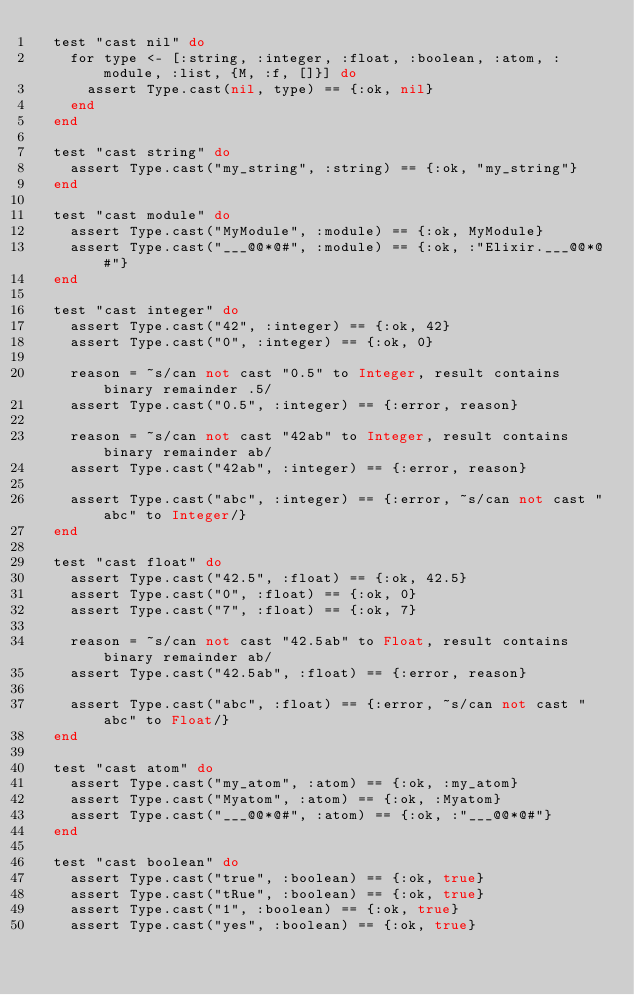Convert code to text. <code><loc_0><loc_0><loc_500><loc_500><_Elixir_>  test "cast nil" do
    for type <- [:string, :integer, :float, :boolean, :atom, :module, :list, {M, :f, []}] do
      assert Type.cast(nil, type) == {:ok, nil}
    end
  end

  test "cast string" do
    assert Type.cast("my_string", :string) == {:ok, "my_string"}
  end

  test "cast module" do
    assert Type.cast("MyModule", :module) == {:ok, MyModule}
    assert Type.cast("___@@*@#", :module) == {:ok, :"Elixir.___@@*@#"}
  end

  test "cast integer" do
    assert Type.cast("42", :integer) == {:ok, 42}
    assert Type.cast("0", :integer) == {:ok, 0}

    reason = ~s/can not cast "0.5" to Integer, result contains binary remainder .5/
    assert Type.cast("0.5", :integer) == {:error, reason}

    reason = ~s/can not cast "42ab" to Integer, result contains binary remainder ab/
    assert Type.cast("42ab", :integer) == {:error, reason}

    assert Type.cast("abc", :integer) == {:error, ~s/can not cast "abc" to Integer/}
  end

  test "cast float" do
    assert Type.cast("42.5", :float) == {:ok, 42.5}
    assert Type.cast("0", :float) == {:ok, 0}
    assert Type.cast("7", :float) == {:ok, 7}

    reason = ~s/can not cast "42.5ab" to Float, result contains binary remainder ab/
    assert Type.cast("42.5ab", :float) == {:error, reason}

    assert Type.cast("abc", :float) == {:error, ~s/can not cast "abc" to Float/}
  end

  test "cast atom" do
    assert Type.cast("my_atom", :atom) == {:ok, :my_atom}
    assert Type.cast("Myatom", :atom) == {:ok, :Myatom}
    assert Type.cast("___@@*@#", :atom) == {:ok, :"___@@*@#"}
  end

  test "cast boolean" do
    assert Type.cast("true", :boolean) == {:ok, true}
    assert Type.cast("tRue", :boolean) == {:ok, true}
    assert Type.cast("1", :boolean) == {:ok, true}
    assert Type.cast("yes", :boolean) == {:ok, true}</code> 